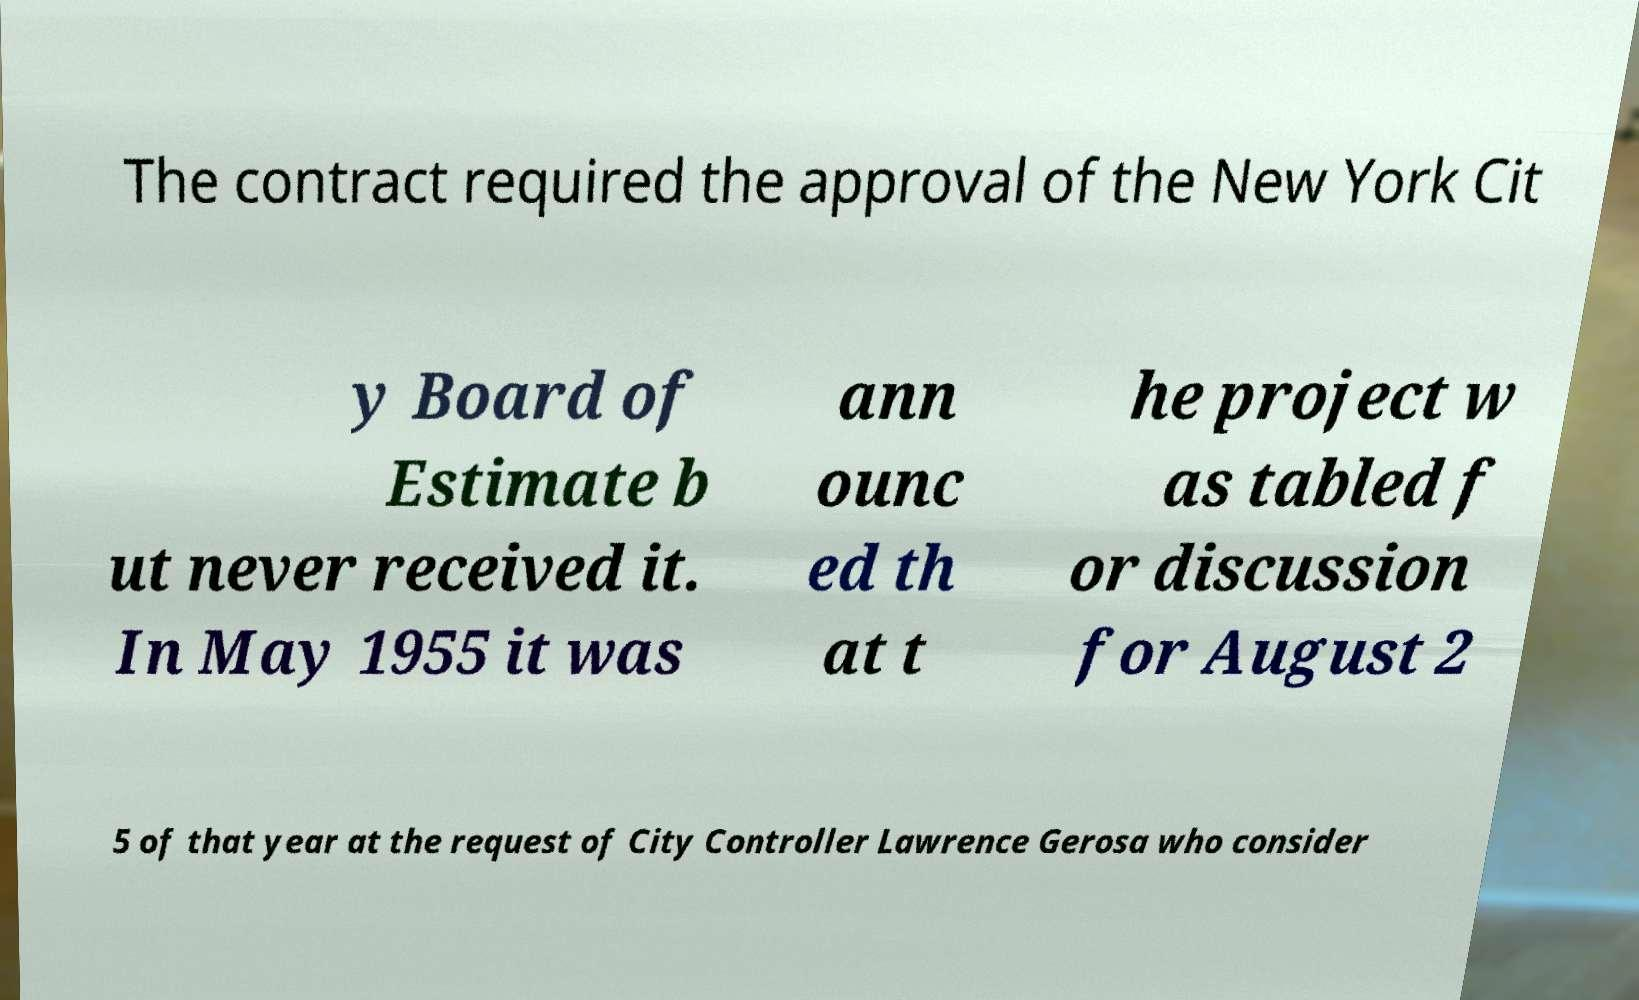Could you assist in decoding the text presented in this image and type it out clearly? The contract required the approval of the New York Cit y Board of Estimate b ut never received it. In May 1955 it was ann ounc ed th at t he project w as tabled f or discussion for August 2 5 of that year at the request of City Controller Lawrence Gerosa who consider 